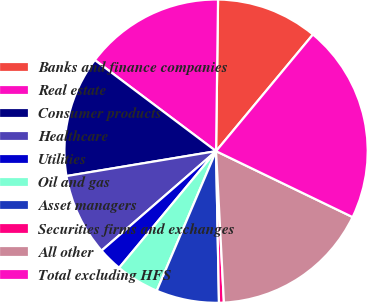Convert chart. <chart><loc_0><loc_0><loc_500><loc_500><pie_chart><fcel>Banks and finance companies<fcel>Real estate<fcel>Consumer products<fcel>Healthcare<fcel>Utilities<fcel>Oil and gas<fcel>Asset managers<fcel>Securities firms and exchanges<fcel>All other<fcel>Total excluding HFS<nl><fcel>10.82%<fcel>14.95%<fcel>12.88%<fcel>8.76%<fcel>2.58%<fcel>4.64%<fcel>6.7%<fcel>0.52%<fcel>17.01%<fcel>21.13%<nl></chart> 